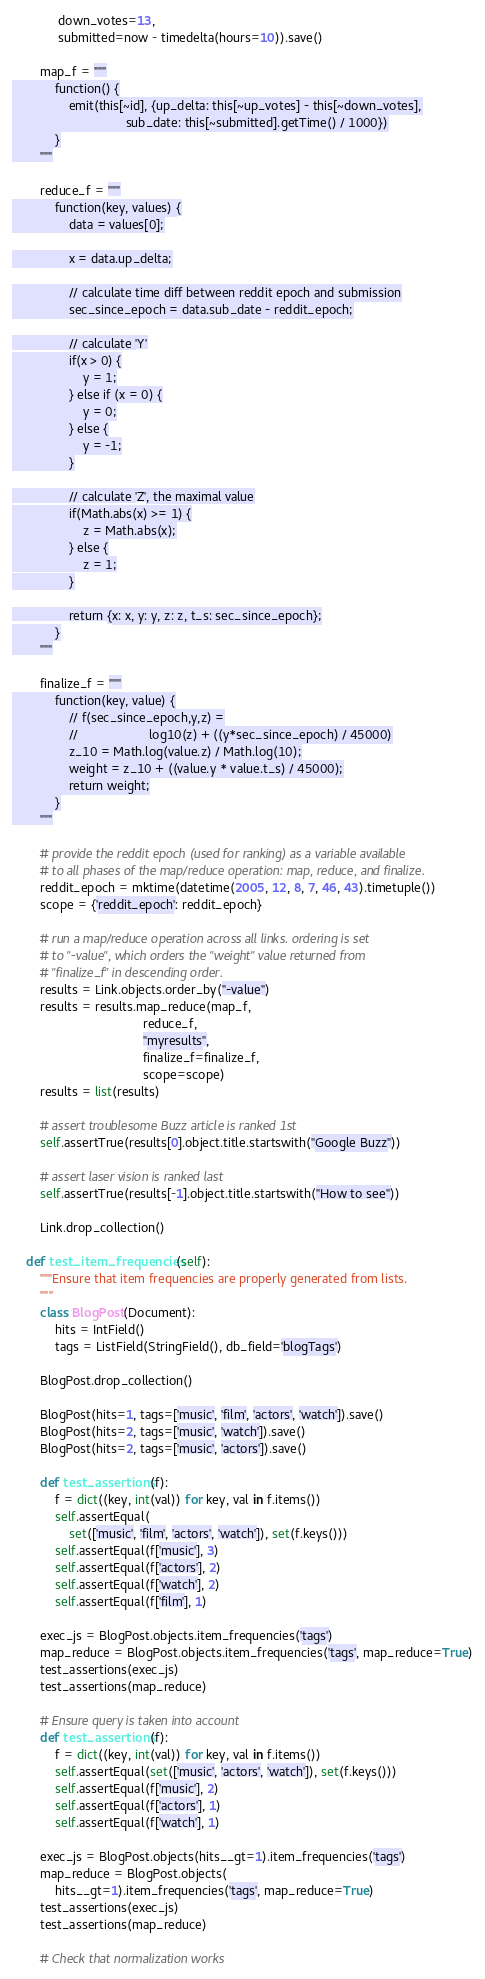<code> <loc_0><loc_0><loc_500><loc_500><_Python_>             down_votes=13,
             submitted=now - timedelta(hours=10)).save()

        map_f = """
            function() {
                emit(this[~id], {up_delta: this[~up_votes] - this[~down_votes],
                                sub_date: this[~submitted].getTime() / 1000})
            }
        """

        reduce_f = """
            function(key, values) {
                data = values[0];

                x = data.up_delta;

                // calculate time diff between reddit epoch and submission
                sec_since_epoch = data.sub_date - reddit_epoch;

                // calculate 'Y'
                if(x > 0) {
                    y = 1;
                } else if (x = 0) {
                    y = 0;
                } else {
                    y = -1;
                }

                // calculate 'Z', the maximal value
                if(Math.abs(x) >= 1) {
                    z = Math.abs(x);
                } else {
                    z = 1;
                }

                return {x: x, y: y, z: z, t_s: sec_since_epoch};
            }
        """

        finalize_f = """
            function(key, value) {
                // f(sec_since_epoch,y,z) =
                //                    log10(z) + ((y*sec_since_epoch) / 45000)
                z_10 = Math.log(value.z) / Math.log(10);
                weight = z_10 + ((value.y * value.t_s) / 45000);
                return weight;
            }
        """

        # provide the reddit epoch (used for ranking) as a variable available
        # to all phases of the map/reduce operation: map, reduce, and finalize.
        reddit_epoch = mktime(datetime(2005, 12, 8, 7, 46, 43).timetuple())
        scope = {'reddit_epoch': reddit_epoch}

        # run a map/reduce operation across all links. ordering is set
        # to "-value", which orders the "weight" value returned from
        # "finalize_f" in descending order.
        results = Link.objects.order_by("-value")
        results = results.map_reduce(map_f,
                                     reduce_f,
                                     "myresults",
                                     finalize_f=finalize_f,
                                     scope=scope)
        results = list(results)

        # assert troublesome Buzz article is ranked 1st
        self.assertTrue(results[0].object.title.startswith("Google Buzz"))

        # assert laser vision is ranked last
        self.assertTrue(results[-1].object.title.startswith("How to see"))

        Link.drop_collection()

    def test_item_frequencies(self):
        """Ensure that item frequencies are properly generated from lists.
        """
        class BlogPost(Document):
            hits = IntField()
            tags = ListField(StringField(), db_field='blogTags')

        BlogPost.drop_collection()

        BlogPost(hits=1, tags=['music', 'film', 'actors', 'watch']).save()
        BlogPost(hits=2, tags=['music', 'watch']).save()
        BlogPost(hits=2, tags=['music', 'actors']).save()

        def test_assertions(f):
            f = dict((key, int(val)) for key, val in f.items())
            self.assertEqual(
                set(['music', 'film', 'actors', 'watch']), set(f.keys()))
            self.assertEqual(f['music'], 3)
            self.assertEqual(f['actors'], 2)
            self.assertEqual(f['watch'], 2)
            self.assertEqual(f['film'], 1)

        exec_js = BlogPost.objects.item_frequencies('tags')
        map_reduce = BlogPost.objects.item_frequencies('tags', map_reduce=True)
        test_assertions(exec_js)
        test_assertions(map_reduce)

        # Ensure query is taken into account
        def test_assertions(f):
            f = dict((key, int(val)) for key, val in f.items())
            self.assertEqual(set(['music', 'actors', 'watch']), set(f.keys()))
            self.assertEqual(f['music'], 2)
            self.assertEqual(f['actors'], 1)
            self.assertEqual(f['watch'], 1)

        exec_js = BlogPost.objects(hits__gt=1).item_frequencies('tags')
        map_reduce = BlogPost.objects(
            hits__gt=1).item_frequencies('tags', map_reduce=True)
        test_assertions(exec_js)
        test_assertions(map_reduce)

        # Check that normalization works</code> 